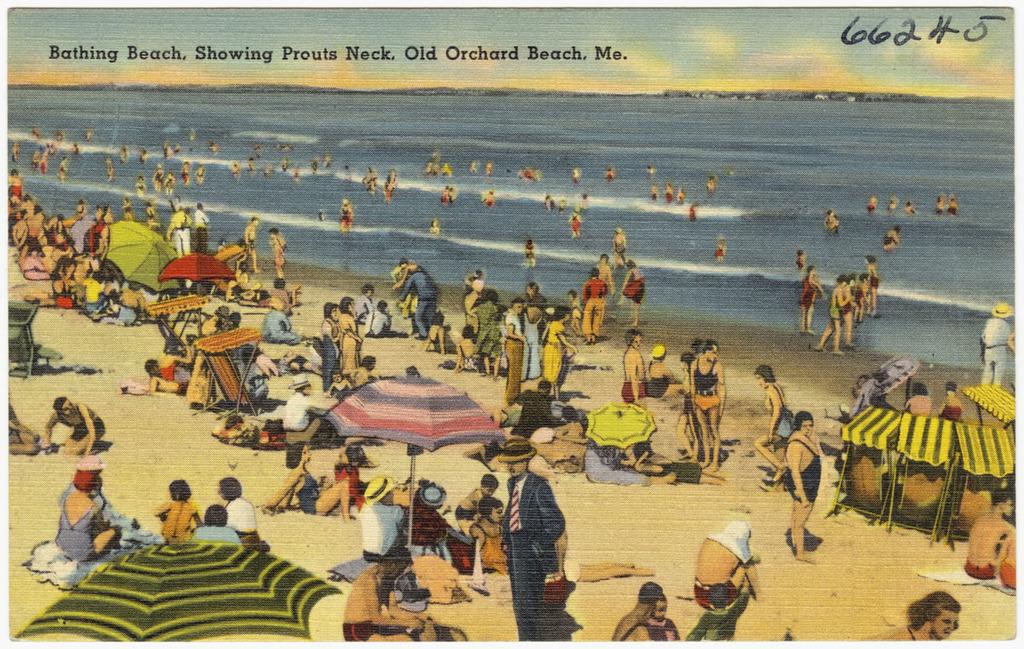What is the name of the beach?
Offer a terse response. Bathing beach. What number is this?
Offer a very short reply. 66245. 